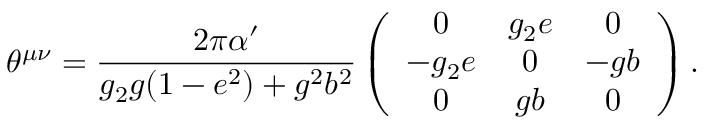Convert formula to latex. <formula><loc_0><loc_0><loc_500><loc_500>\theta ^ { \mu \nu } = \frac { 2 \pi \alpha ^ { \prime } } { g _ { 2 } g ( 1 - e ^ { 2 } ) + g ^ { 2 } b ^ { 2 } } \left ( \begin{array} { c c c } { 0 } & { { g _ { 2 } e } } & { 0 } \\ { { - g _ { 2 } e } } & { 0 } & { - g b } \\ { 0 } & { g b } & { 0 } \end{array} \right ) .</formula> 